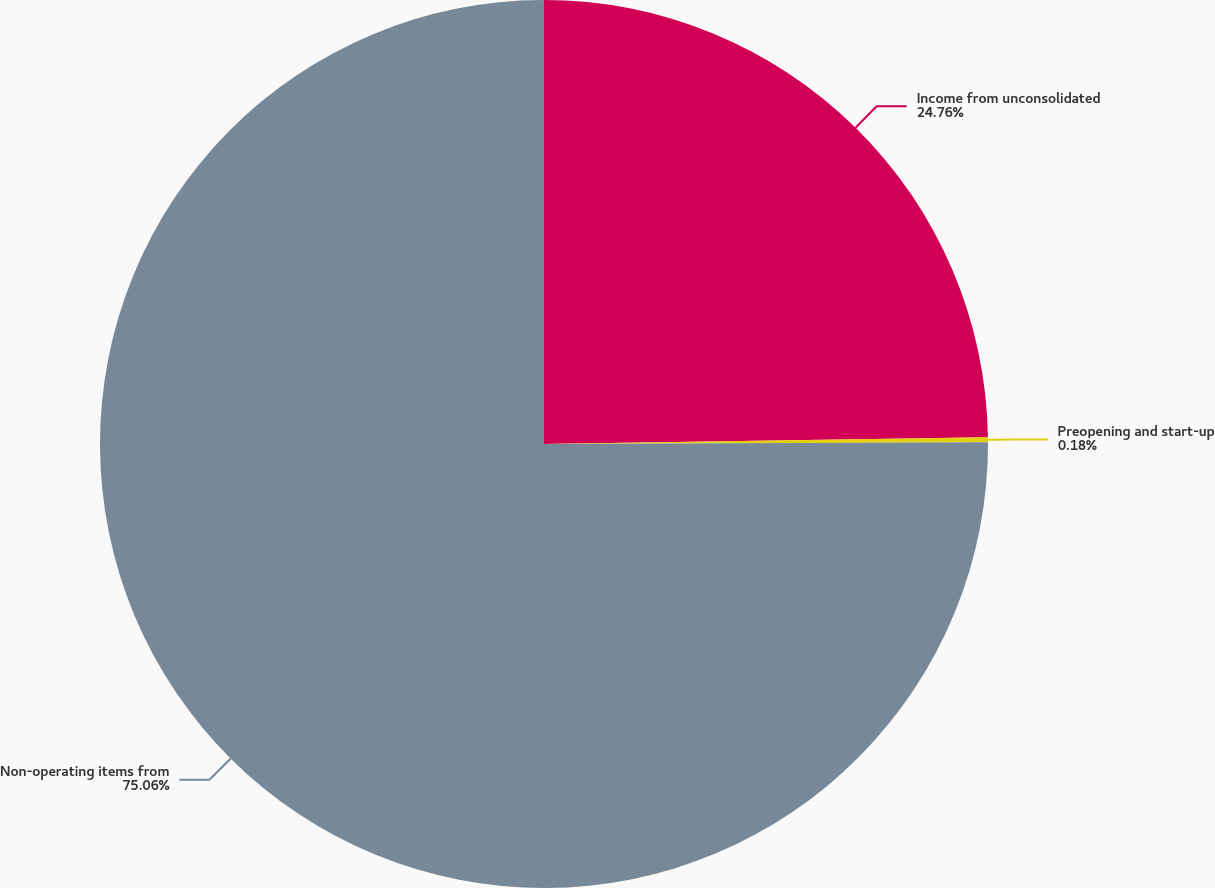Convert chart to OTSL. <chart><loc_0><loc_0><loc_500><loc_500><pie_chart><fcel>Income from unconsolidated<fcel>Preopening and start-up<fcel>Non-operating items from<nl><fcel>24.76%<fcel>0.18%<fcel>75.06%<nl></chart> 